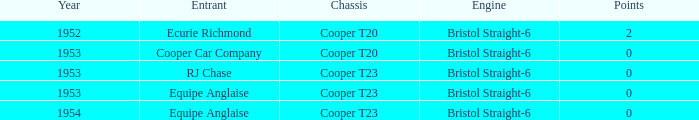How many years experienced a point count above 0? 1952.0. 